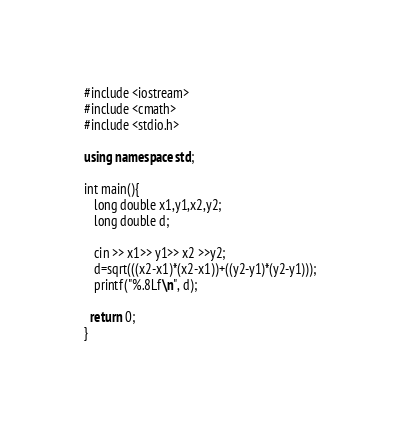Convert code to text. <code><loc_0><loc_0><loc_500><loc_500><_C++_>#include <iostream>
#include <cmath>
#include <stdio.h>

using namespace std;

int main(){
   long double x1,y1,x2,y2;
   long double d;

   cin >> x1>> y1>> x2 >>y2;
   d=sqrt(((x2-x1)*(x2-x1))+((y2-y1)*(y2-y1)));
   printf("%.8Lf\n", d);
  
  return 0;
}

</code> 